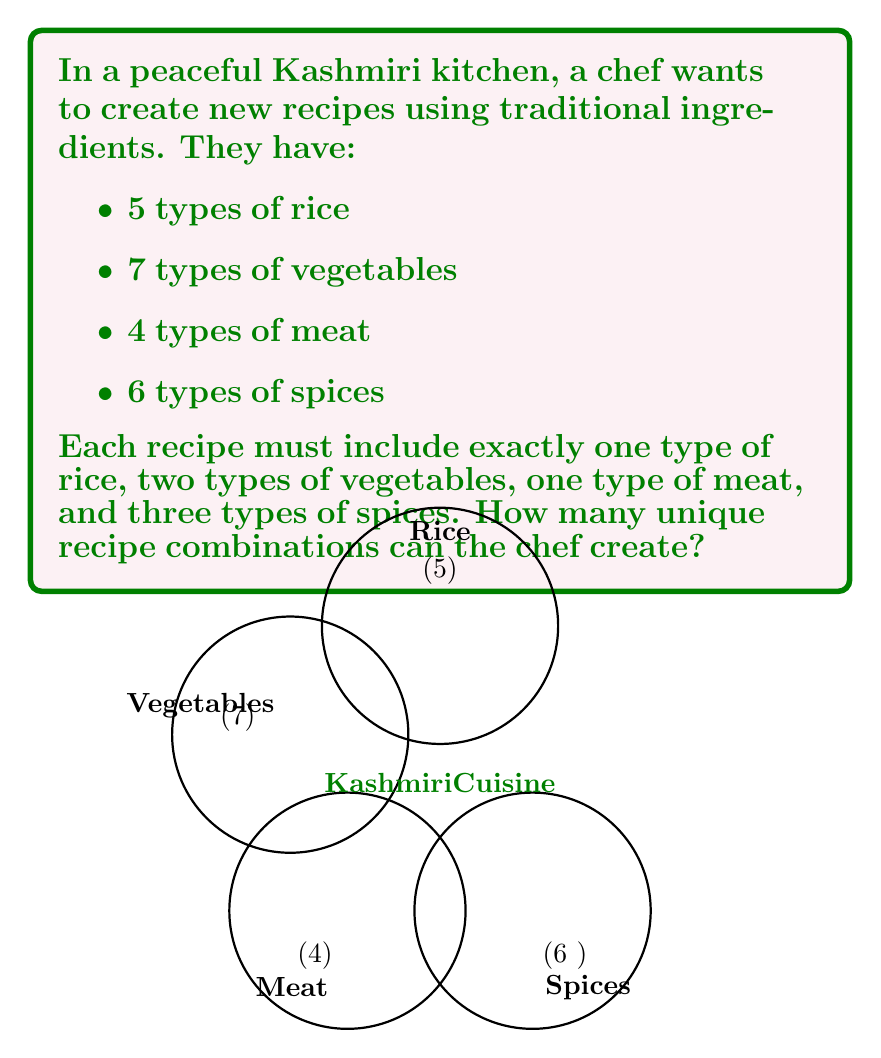Provide a solution to this math problem. Let's approach this step-by-step using the multiplication principle from combinatorics:

1) For rice: The chef must choose 1 out of 5 types. This can be done in $\binom{5}{1} = 5$ ways.

2) For vegetables: The chef must choose 2 out of 7 types. This can be done in $\binom{7}{2} = \frac{7!}{2!(7-2)!} = \frac{7 \cdot 6}{2 \cdot 1} = 21$ ways.

3) For meat: The chef must choose 1 out of 4 types. This can be done in $\binom{4}{1} = 4$ ways.

4) For spices: The chef must choose 3 out of 6 types. This can be done in $\binom{6}{3} = \frac{6!}{3!(6-3)!} = \frac{6 \cdot 5 \cdot 4}{3 \cdot 2 \cdot 1} = 20$ ways.

Now, according to the multiplication principle, if we have a sequence of choices where we have $m$ ways of making the first choice, $n$ ways of making the second choice, $p$ ways of making the third choice, and so on, then the total number of ways to make the sequence of choices is $m \times n \times p \times \cdots$

Therefore, the total number of unique recipe combinations is:

$$5 \times 21 \times 4 \times 20 = 8400$$

This calculation ensures a wide variety of peaceful culinary experiences, promoting cultural richness without any political overtones.
Answer: 8400 unique recipe combinations 